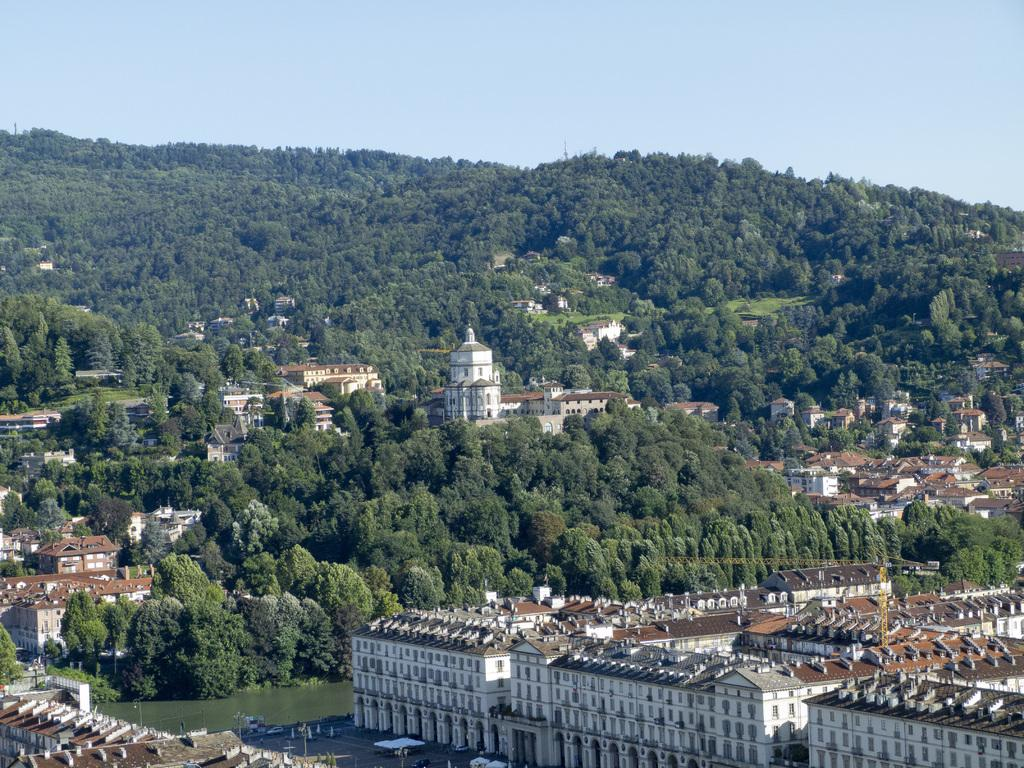What type of vegetation is present in the image? There are green trees in the image. What type of structures can be seen in the image? There are buildings in the image. What natural element is visible in the image? Water is visible in the image. What is visible at the top of the image? The sky is visible at the top of the image. What type of grain is being taxed in the image? There is no reference to grain or taxation in the image. How many snakes are visible in the image? There are no snakes present in the image. 